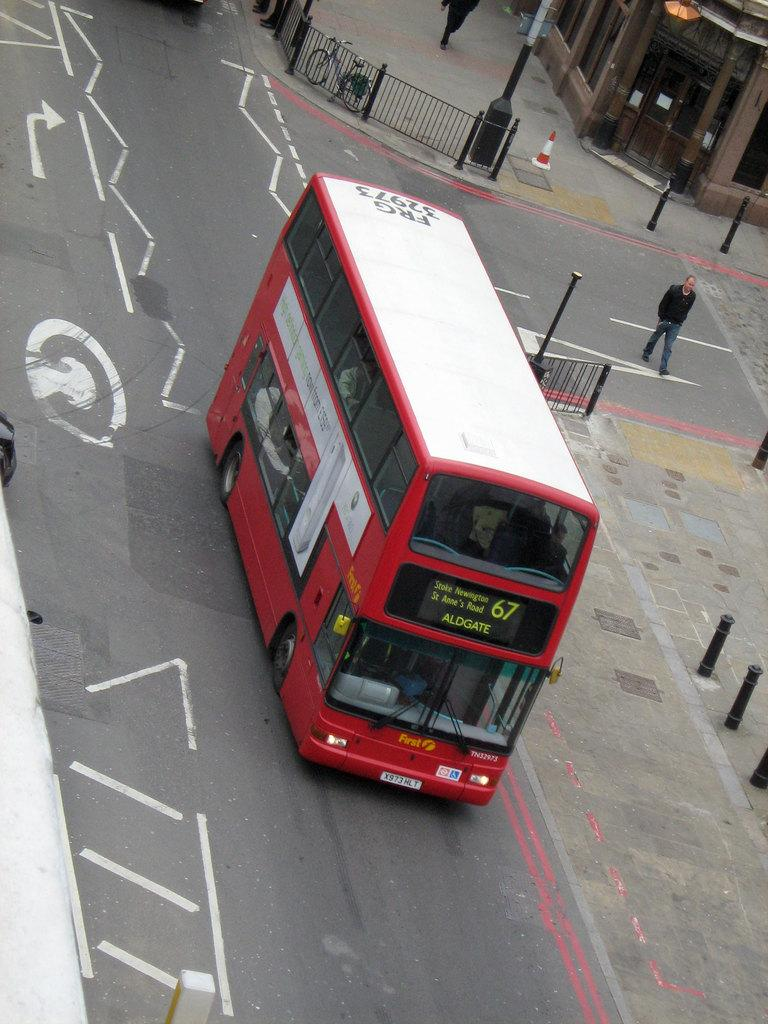What is the main subject of the image? The main subject of the image is a bus. Where is the bus located in the image? The bus is on the road in the middle of the image. What can be seen in the background of the image? In the background of the image, there is a fence, poles, buildings, and two persons. When was the image taken? The image was taken during the day. How many frogs are jumping on the bus in the image? There are no frogs present in the image, and therefore no such activity can be observed. 